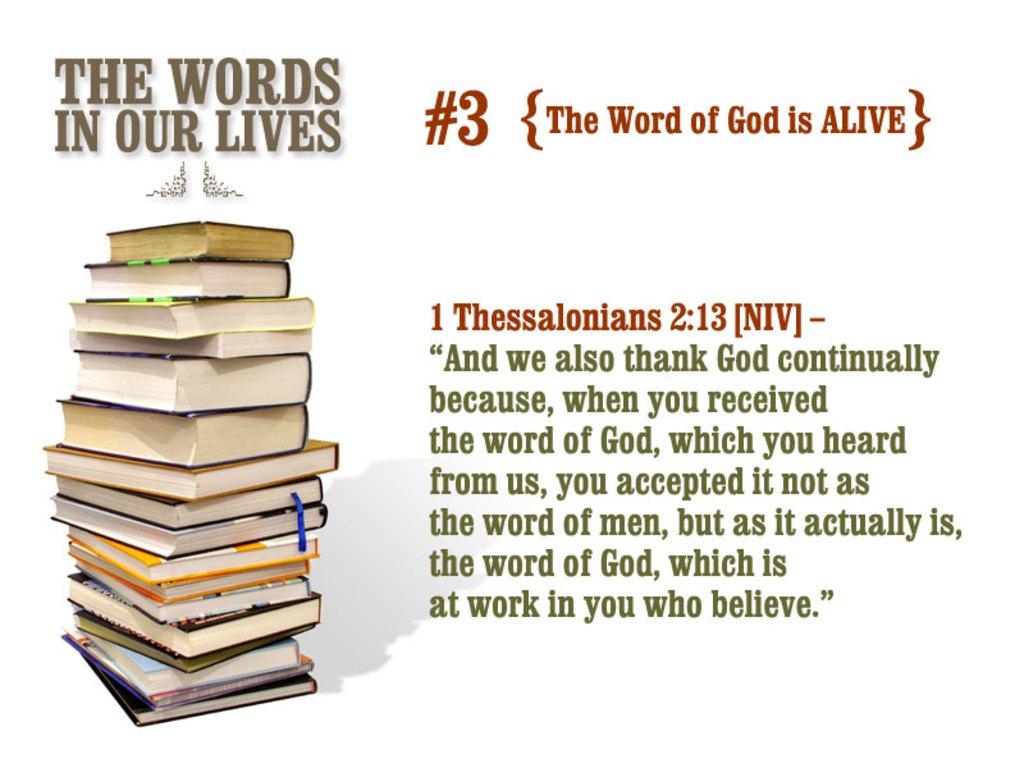Provide a one-sentence caption for the provided image. A stack of books with the words above that say The Words In Our Lives. 